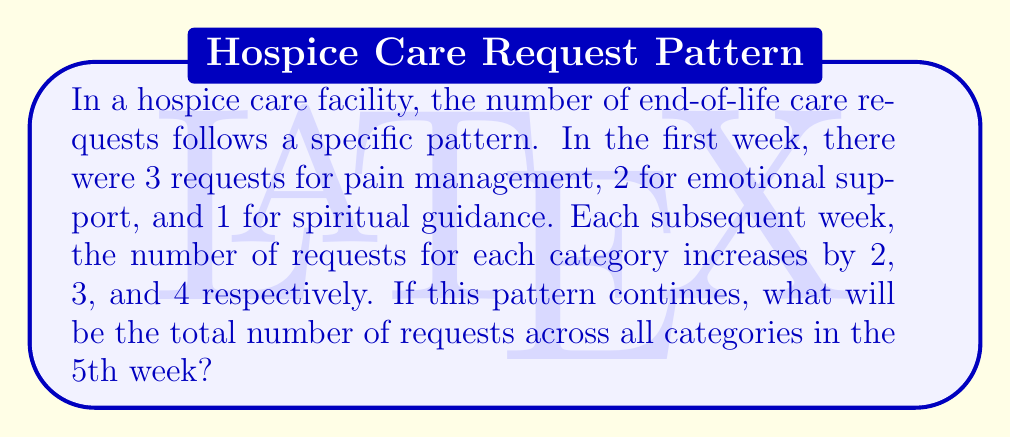Could you help me with this problem? Let's break this down step-by-step:

1) First, let's identify the sequence for each category:

   Pain management: 3, 5, 7, 9, 11
   Emotional support: 2, 5, 8, 11, 14
   Spiritual guidance: 1, 5, 9, 13, 17

2) We can represent these sequences mathematically:

   Pain management: $a_n = 3 + 2(n-1)$
   Emotional support: $b_n = 2 + 3(n-1)$
   Spiritual guidance: $c_n = 1 + 4(n-1)$

   Where $n$ is the week number.

3) For the 5th week, we need to calculate:

   Pain management: $a_5 = 3 + 2(5-1) = 3 + 8 = 11$
   Emotional support: $b_5 = 2 + 3(5-1) = 2 + 12 = 14$
   Spiritual guidance: $c_5 = 1 + 4(5-1) = 1 + 16 = 17$

4) To get the total number of requests in the 5th week, we sum these values:

   Total = $a_5 + b_5 + c_5 = 11 + 14 + 17 = 42$

Therefore, in the 5th week, there will be a total of 42 requests across all categories.
Answer: 42 